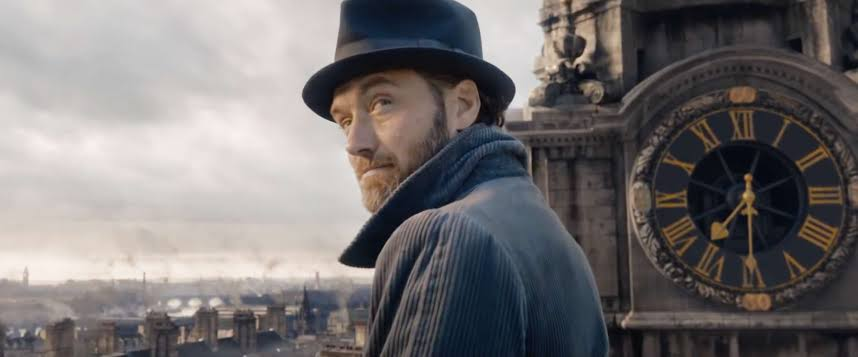What do you see happening in this image? In the image, we see a person standing on a rooftop with an expansive view of the city skyline behind them. The large, ornate clock in the background suggests a setting that is likely historically significant or part of a narrative context. The individual is dressed formally, sporting a blue coat and a black hat, which could hint at a particular role or character. They appear reflective, gazing into the distance, which might imply a moment of decision or contemplation. 